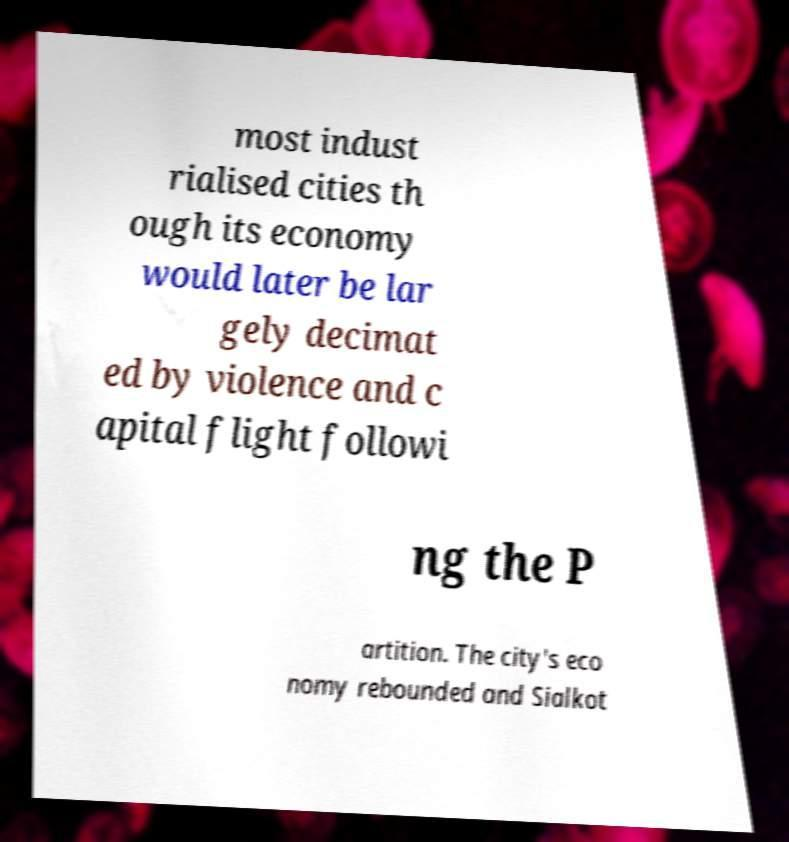Please read and relay the text visible in this image. What does it say? most indust rialised cities th ough its economy would later be lar gely decimat ed by violence and c apital flight followi ng the P artition. The city's eco nomy rebounded and Sialkot 